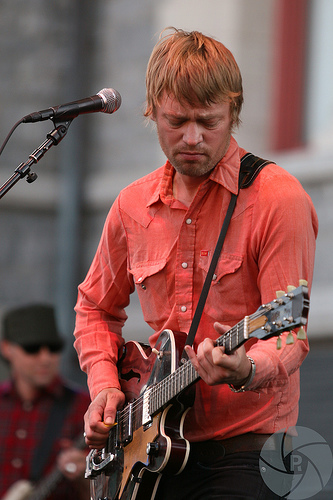<image>
Can you confirm if the mic is on the guitar? No. The mic is not positioned on the guitar. They may be near each other, but the mic is not supported by or resting on top of the guitar. Is there a red hair above the guitar? Yes. The red hair is positioned above the guitar in the vertical space, higher up in the scene. 